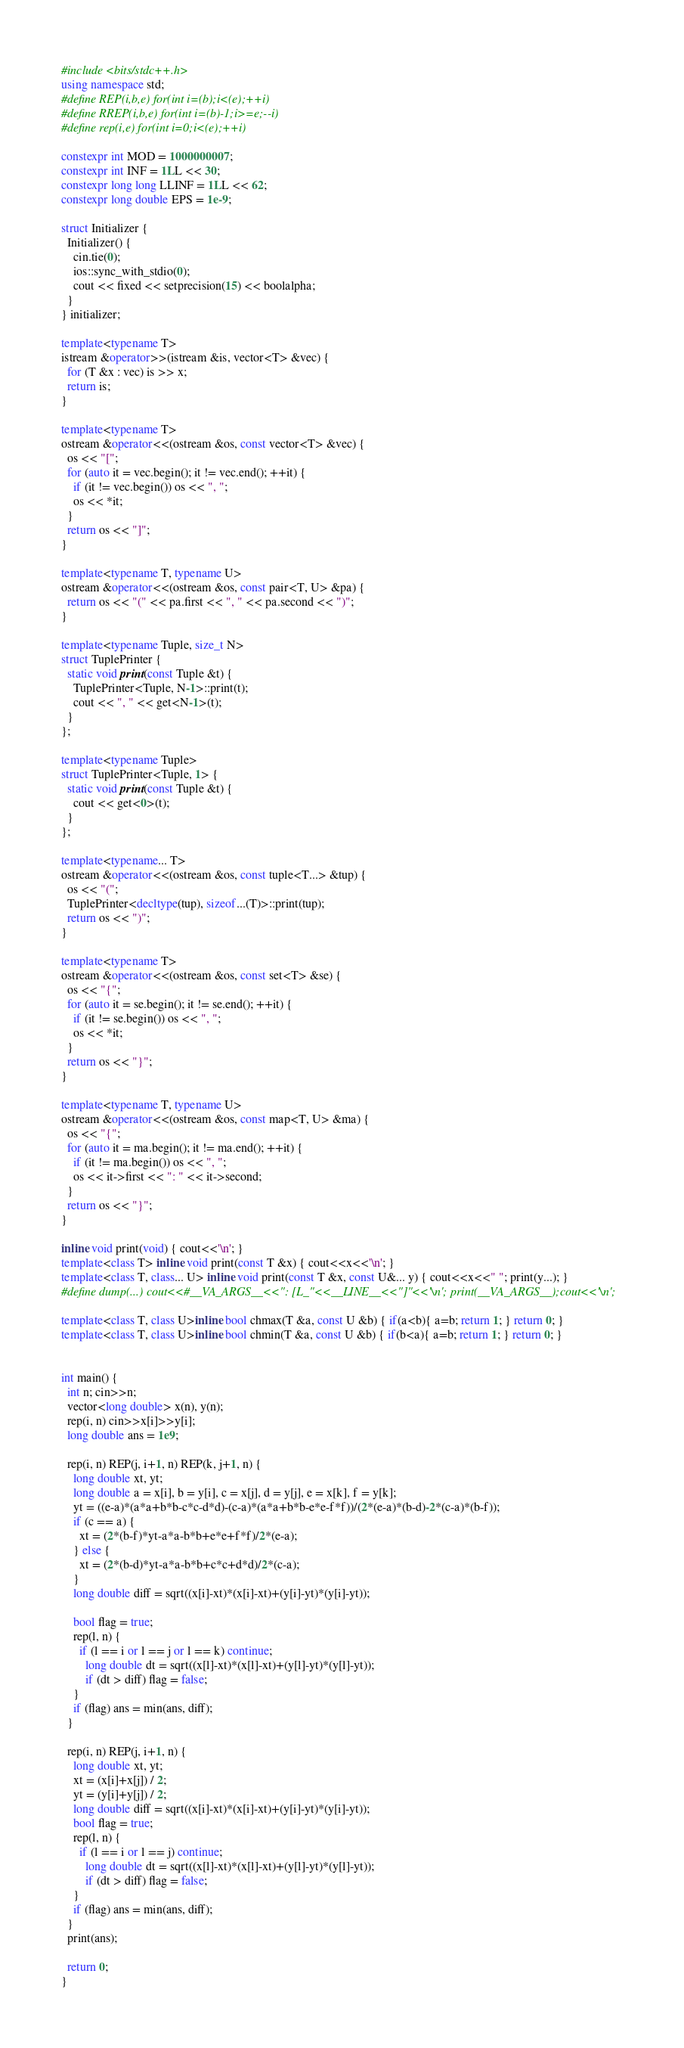<code> <loc_0><loc_0><loc_500><loc_500><_C++_>#include <bits/stdc++.h>
using namespace std;
#define REP(i,b,e) for(int i=(b);i<(e);++i)
#define RREP(i,b,e) for(int i=(b)-1;i>=e;--i)
#define rep(i,e) for(int i=0;i<(e);++i)

constexpr int MOD = 1000000007;
constexpr int INF = 1LL << 30;
constexpr long long LLINF = 1LL << 62;
constexpr long double EPS = 1e-9;

struct Initializer {
  Initializer() {
    cin.tie(0);
    ios::sync_with_stdio(0);
    cout << fixed << setprecision(15) << boolalpha;
  }
} initializer;

template<typename T>
istream &operator>>(istream &is, vector<T> &vec) {
  for (T &x : vec) is >> x;
  return is;
}

template<typename T>
ostream &operator<<(ostream &os, const vector<T> &vec) {
  os << "[";
  for (auto it = vec.begin(); it != vec.end(); ++it) {
    if (it != vec.begin()) os << ", ";
    os << *it;
  }
  return os << "]";
}

template<typename T, typename U>
ostream &operator<<(ostream &os, const pair<T, U> &pa) {
  return os << "(" << pa.first << ", " << pa.second << ")";
}

template<typename Tuple, size_t N>
struct TuplePrinter {
  static void print(const Tuple &t) {
    TuplePrinter<Tuple, N-1>::print(t);
    cout << ", " << get<N-1>(t);
  }
};

template<typename Tuple>
struct TuplePrinter<Tuple, 1> {
  static void print(const Tuple &t) {
    cout << get<0>(t);
  }
};

template<typename... T>
ostream &operator<<(ostream &os, const tuple<T...> &tup) {
  os << "(";
  TuplePrinter<decltype(tup), sizeof...(T)>::print(tup);
  return os << ")";
}

template<typename T>
ostream &operator<<(ostream &os, const set<T> &se) {
  os << "{";
  for (auto it = se.begin(); it != se.end(); ++it) {
    if (it != se.begin()) os << ", ";
    os << *it;
  }
  return os << "}";
}

template<typename T, typename U>
ostream &operator<<(ostream &os, const map<T, U> &ma) {
  os << "{";
  for (auto it = ma.begin(); it != ma.end(); ++it) {
    if (it != ma.begin()) os << ", ";
    os << it->first << ": " << it->second;
  }
  return os << "}";
}

inline void print(void) { cout<<'\n'; }
template<class T> inline void print(const T &x) { cout<<x<<'\n'; }
template<class T, class... U> inline void print(const T &x, const U&... y) { cout<<x<<" "; print(y...); }
#define dump(...) cout<<#__VA_ARGS__<<": [L_"<<__LINE__<<"]"<<'\n'; print(__VA_ARGS__);cout<<'\n';

template<class T, class U>inline bool chmax(T &a, const U &b) { if(a<b){ a=b; return 1; } return 0; }
template<class T, class U>inline bool chmin(T &a, const U &b) { if(b<a){ a=b; return 1; } return 0; }


int main() {
  int n; cin>>n;
  vector<long double> x(n), y(n);
  rep(i, n) cin>>x[i]>>y[i];
  long double ans = 1e9;

  rep(i, n) REP(j, i+1, n) REP(k, j+1, n) {
    long double xt, yt;
    long double a = x[i], b = y[i], c = x[j], d = y[j], e = x[k], f = y[k];
    yt = ((e-a)*(a*a+b*b-c*c-d*d)-(c-a)*(a*a+b*b-e*e-f*f))/(2*(e-a)*(b-d)-2*(c-a)*(b-f));
    if (c == a) {
      xt = (2*(b-f)*yt-a*a-b*b+e*e+f*f)/2*(e-a);
    } else {
      xt = (2*(b-d)*yt-a*a-b*b+c*c+d*d)/2*(c-a);
    }
    long double diff = sqrt((x[i]-xt)*(x[i]-xt)+(y[i]-yt)*(y[i]-yt));
    
    bool flag = true;
    rep(l, n) {
      if (l == i or l == j or l == k) continue;
        long double dt = sqrt((x[l]-xt)*(x[l]-xt)+(y[l]-yt)*(y[l]-yt));
        if (dt > diff) flag = false;
    }
    if (flag) ans = min(ans, diff);
  }

  rep(i, n) REP(j, i+1, n) {
    long double xt, yt;
    xt = (x[i]+x[j]) / 2;
    yt = (y[i]+y[j]) / 2;
    long double diff = sqrt((x[i]-xt)*(x[i]-xt)+(y[i]-yt)*(y[i]-yt));
    bool flag = true;
    rep(l, n) {
      if (l == i or l == j) continue;
        long double dt = sqrt((x[l]-xt)*(x[l]-xt)+(y[l]-yt)*(y[l]-yt));
        if (dt > diff) flag = false;
    }
    if (flag) ans = min(ans, diff);
  }
  print(ans);

  return 0;
}</code> 